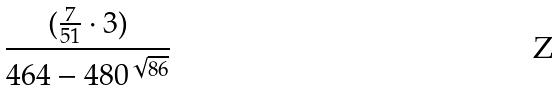Convert formula to latex. <formula><loc_0><loc_0><loc_500><loc_500>\frac { ( \frac { 7 } { 5 1 } \cdot 3 ) } { 4 6 4 - 4 8 0 ^ { \sqrt { 8 6 } } }</formula> 